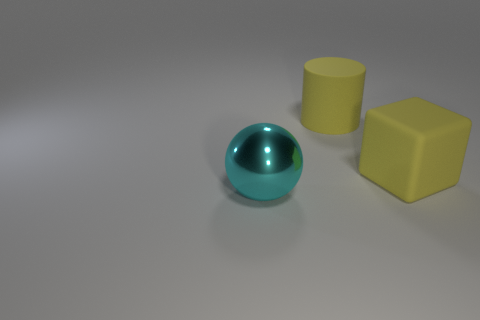Add 1 big rubber things. How many big rubber things are left? 3 Add 3 blocks. How many blocks exist? 4 Add 3 red blocks. How many objects exist? 6 Subtract 0 cyan cylinders. How many objects are left? 3 Subtract all balls. How many objects are left? 2 Subtract all purple cubes. How many cyan cylinders are left? 0 Subtract all big spheres. Subtract all big cyan metal things. How many objects are left? 1 